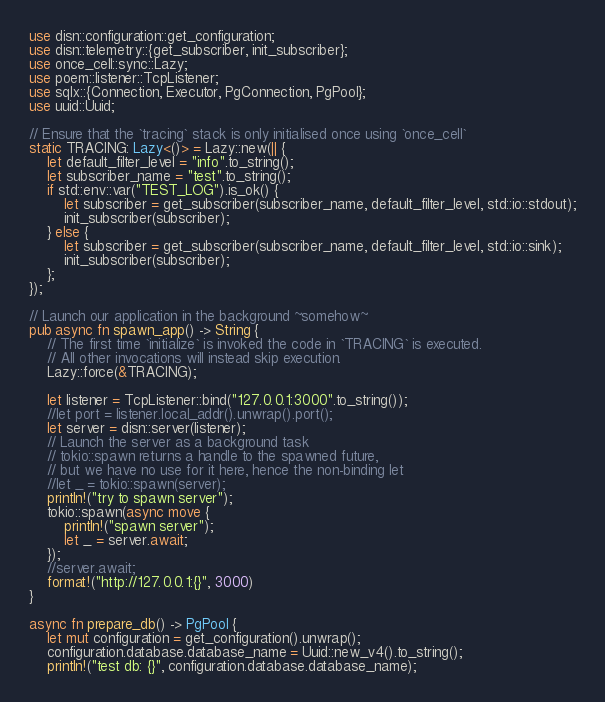Convert code to text. <code><loc_0><loc_0><loc_500><loc_500><_Rust_>use disn::configuration::get_configuration;
use disn::telemetry::{get_subscriber, init_subscriber};
use once_cell::sync::Lazy;
use poem::listener::TcpListener;
use sqlx::{Connection, Executor, PgConnection, PgPool};
use uuid::Uuid;

// Ensure that the `tracing` stack is only initialised once using `once_cell`
static TRACING: Lazy<()> = Lazy::new(|| {
    let default_filter_level = "info".to_string();
    let subscriber_name = "test".to_string();
    if std::env::var("TEST_LOG").is_ok() {
        let subscriber = get_subscriber(subscriber_name, default_filter_level, std::io::stdout);
        init_subscriber(subscriber);
    } else {
        let subscriber = get_subscriber(subscriber_name, default_filter_level, std::io::sink);
        init_subscriber(subscriber);
    };
});

// Launch our application in the background ~somehow~
pub async fn spawn_app() -> String {
    // The first time `initialize` is invoked the code in `TRACING` is executed.
    // All other invocations will instead skip execution.
    Lazy::force(&TRACING);

    let listener = TcpListener::bind("127.0.0.1:3000".to_string());
    //let port = listener.local_addr().unwrap().port();
    let server = disn::server(listener);
    // Launch the server as a background task
    // tokio::spawn returns a handle to the spawned future,
    // but we have no use for it here, hence the non-binding let
    //let _ = tokio::spawn(server);
    println!("try to spawn server");
    tokio::spawn(async move {
        println!("spawn server");
        let _ = server.await;
    });
    //server.await;
    format!("http://127.0.0.1:{}", 3000)
}

async fn prepare_db() -> PgPool {
    let mut configuration = get_configuration().unwrap();
    configuration.database.database_name = Uuid::new_v4().to_string();
    println!("test db: {}", configuration.database.database_name);
</code> 